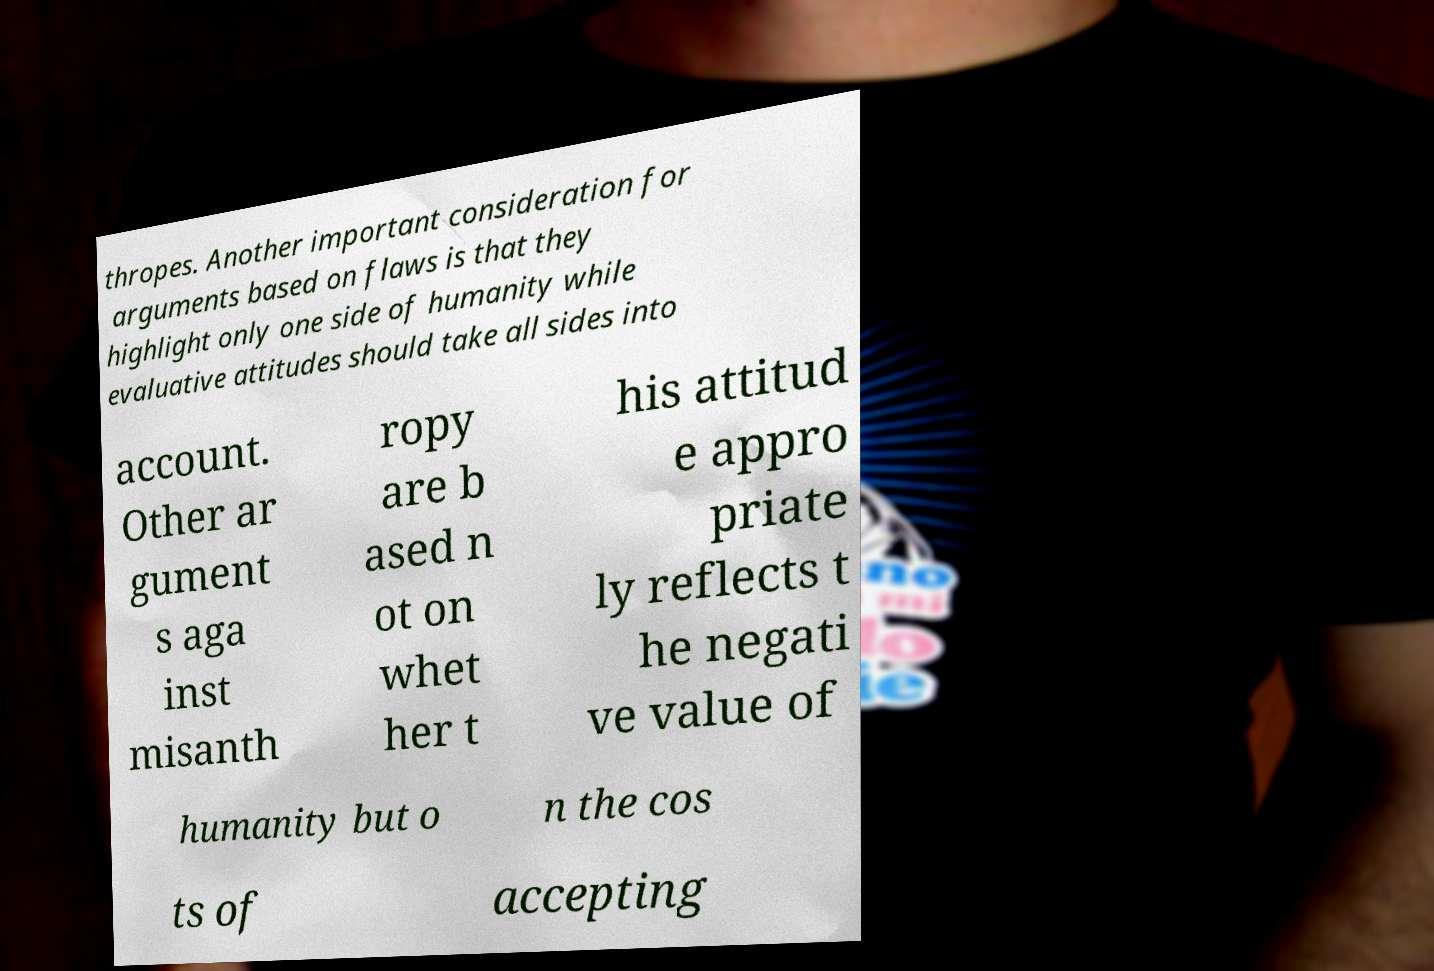There's text embedded in this image that I need extracted. Can you transcribe it verbatim? thropes. Another important consideration for arguments based on flaws is that they highlight only one side of humanity while evaluative attitudes should take all sides into account. Other ar gument s aga inst misanth ropy are b ased n ot on whet her t his attitud e appro priate ly reflects t he negati ve value of humanity but o n the cos ts of accepting 